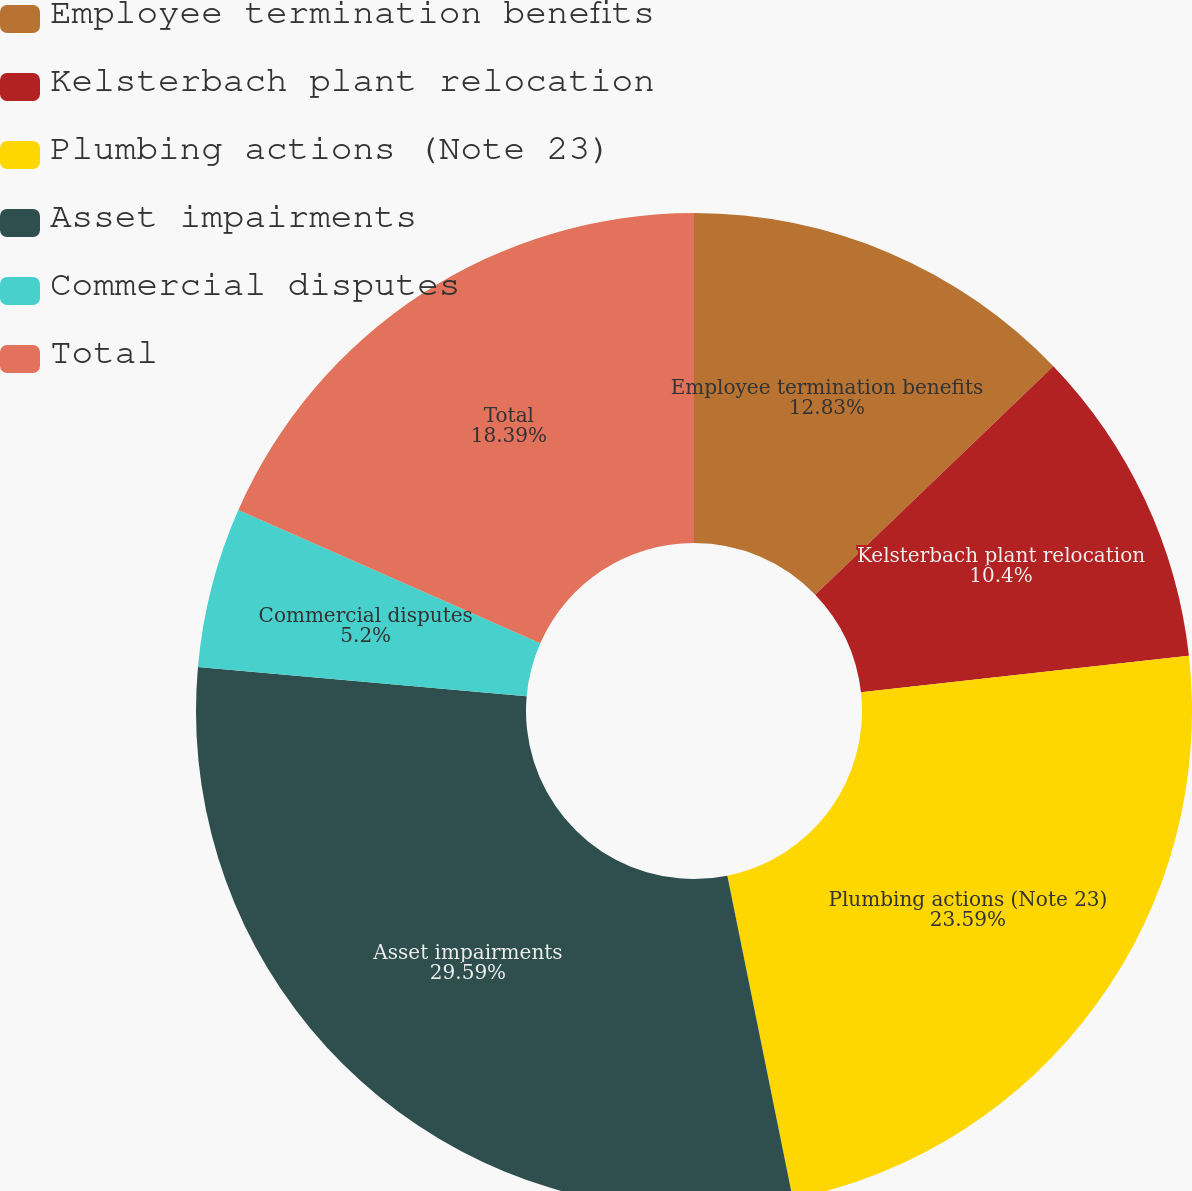Convert chart to OTSL. <chart><loc_0><loc_0><loc_500><loc_500><pie_chart><fcel>Employee termination benefits<fcel>Kelsterbach plant relocation<fcel>Plumbing actions (Note 23)<fcel>Asset impairments<fcel>Commercial disputes<fcel>Total<nl><fcel>12.83%<fcel>10.4%<fcel>23.59%<fcel>29.59%<fcel>5.2%<fcel>18.39%<nl></chart> 